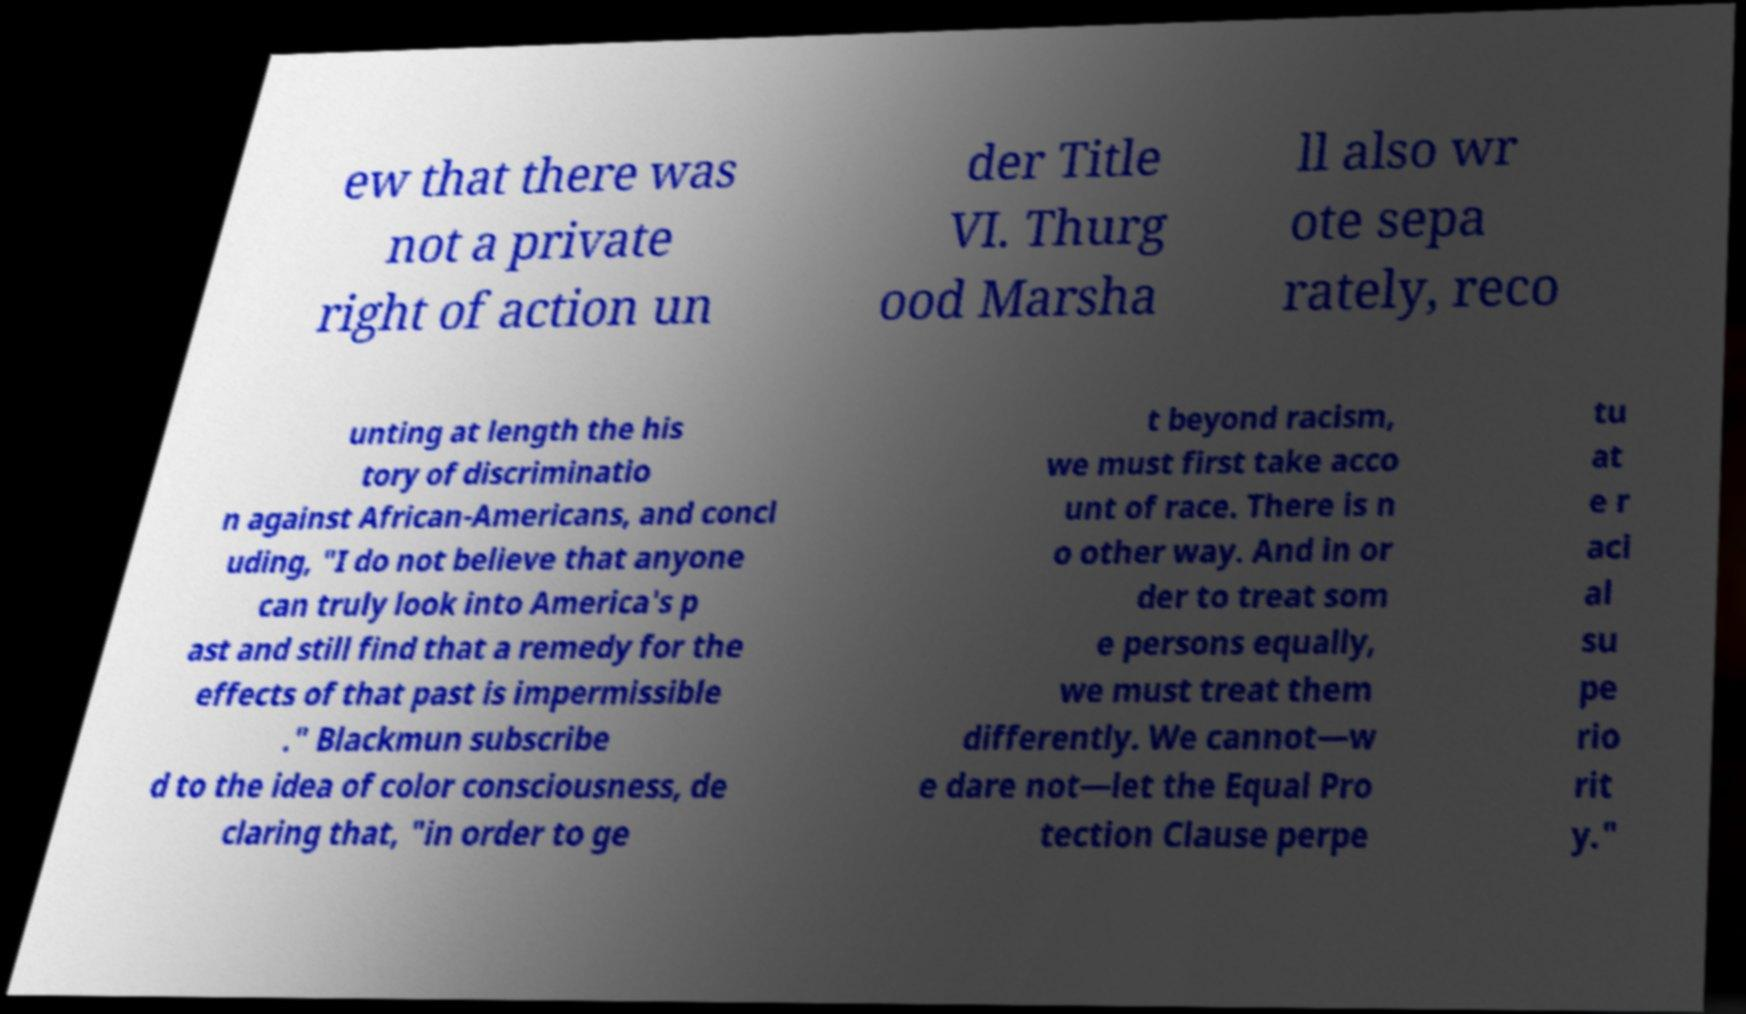There's text embedded in this image that I need extracted. Can you transcribe it verbatim? ew that there was not a private right of action un der Title VI. Thurg ood Marsha ll also wr ote sepa rately, reco unting at length the his tory of discriminatio n against African-Americans, and concl uding, "I do not believe that anyone can truly look into America's p ast and still find that a remedy for the effects of that past is impermissible ." Blackmun subscribe d to the idea of color consciousness, de claring that, "in order to ge t beyond racism, we must first take acco unt of race. There is n o other way. And in or der to treat som e persons equally, we must treat them differently. We cannot—w e dare not—let the Equal Pro tection Clause perpe tu at e r aci al su pe rio rit y." 